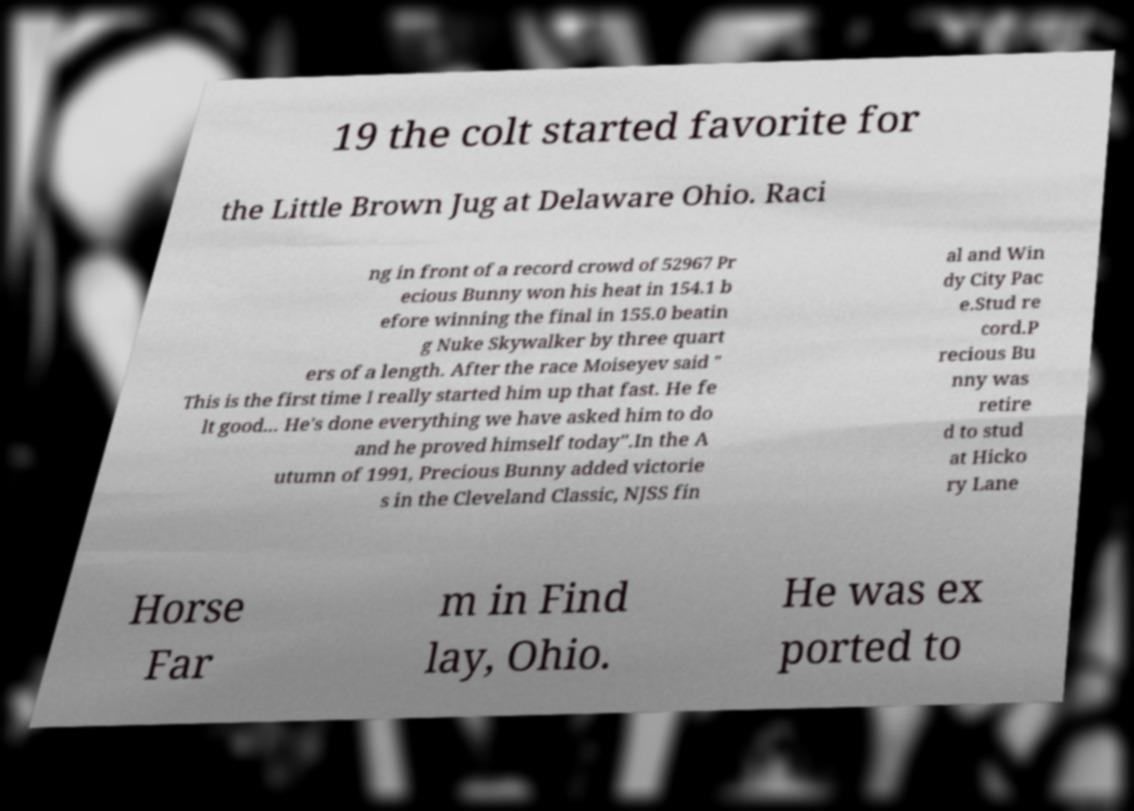Please identify and transcribe the text found in this image. 19 the colt started favorite for the Little Brown Jug at Delaware Ohio. Raci ng in front of a record crowd of 52967 Pr ecious Bunny won his heat in 154.1 b efore winning the final in 155.0 beatin g Nuke Skywalker by three quart ers of a length. After the race Moiseyev said " This is the first time I really started him up that fast. He fe lt good... He's done everything we have asked him to do and he proved himself today".In the A utumn of 1991, Precious Bunny added victorie s in the Cleveland Classic, NJSS fin al and Win dy City Pac e.Stud re cord.P recious Bu nny was retire d to stud at Hicko ry Lane Horse Far m in Find lay, Ohio. He was ex ported to 